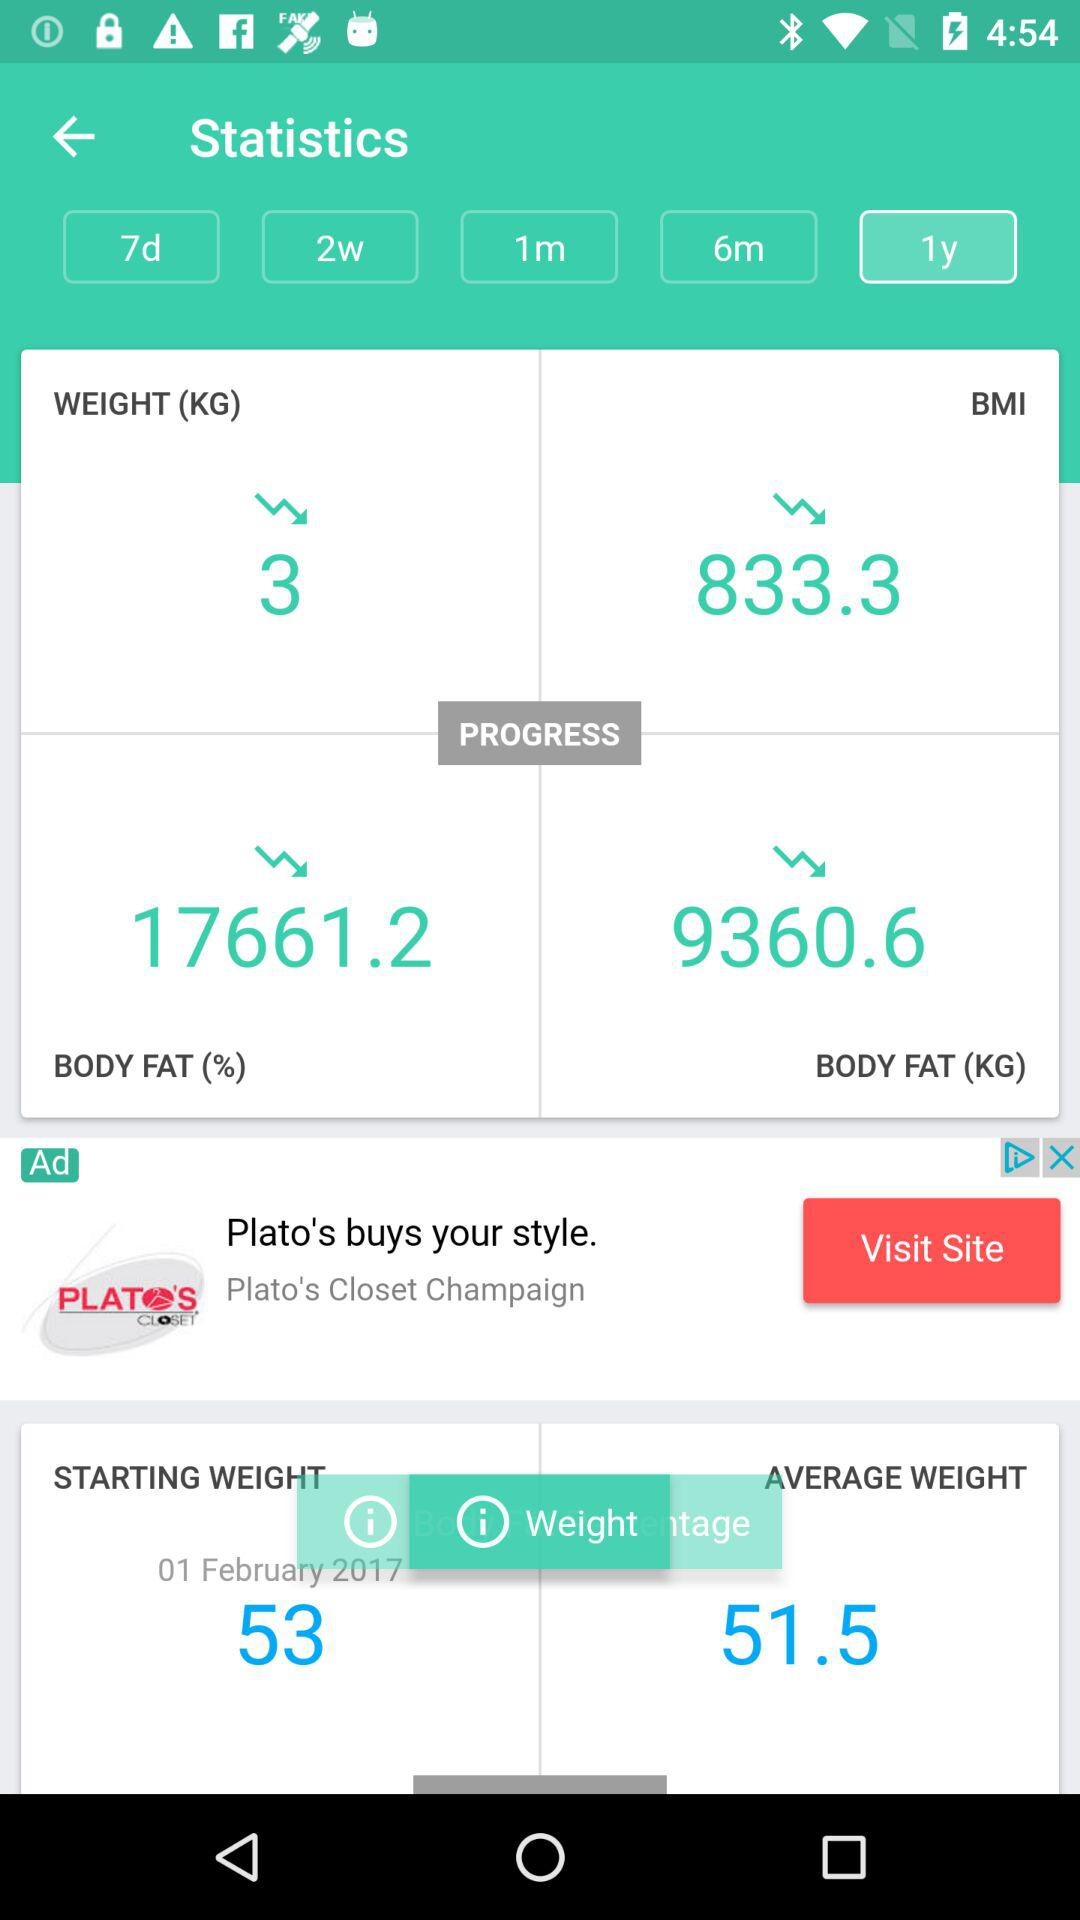How much body fat decreased in KG? Body fat decreased in kg is 9360.6. 